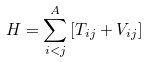Convert formula to latex. <formula><loc_0><loc_0><loc_500><loc_500>H = \sum _ { i < j } ^ { A } \left [ T _ { i j } + V _ { i j } \right ]</formula> 